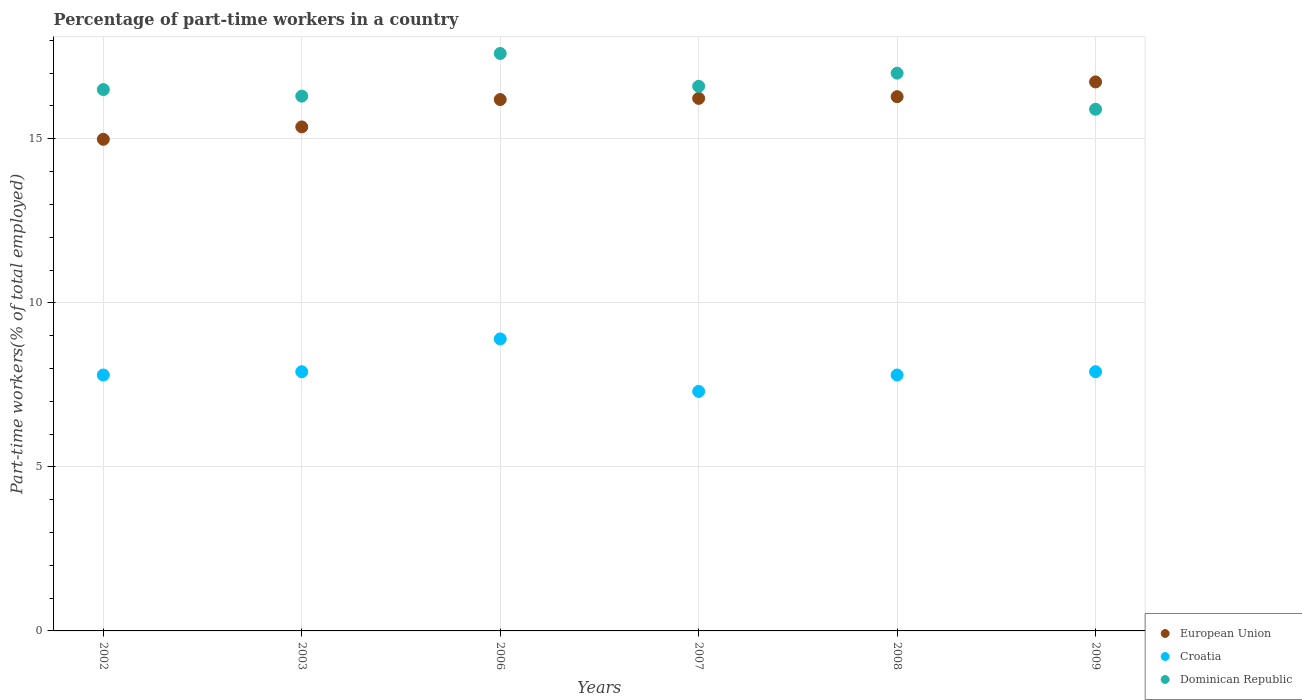How many different coloured dotlines are there?
Provide a short and direct response. 3. What is the percentage of part-time workers in Dominican Republic in 2008?
Give a very brief answer. 17. Across all years, what is the maximum percentage of part-time workers in Croatia?
Provide a short and direct response. 8.9. Across all years, what is the minimum percentage of part-time workers in Dominican Republic?
Make the answer very short. 15.9. What is the total percentage of part-time workers in European Union in the graph?
Give a very brief answer. 95.79. What is the difference between the percentage of part-time workers in Dominican Republic in 2008 and that in 2009?
Your answer should be compact. 1.1. What is the difference between the percentage of part-time workers in Dominican Republic in 2006 and the percentage of part-time workers in Croatia in 2002?
Make the answer very short. 9.8. What is the average percentage of part-time workers in European Union per year?
Your answer should be compact. 15.96. In the year 2006, what is the difference between the percentage of part-time workers in European Union and percentage of part-time workers in Croatia?
Your response must be concise. 7.3. In how many years, is the percentage of part-time workers in European Union greater than 9 %?
Offer a very short reply. 6. What is the ratio of the percentage of part-time workers in European Union in 2007 to that in 2009?
Provide a succinct answer. 0.97. Is the percentage of part-time workers in Croatia in 2007 less than that in 2009?
Offer a terse response. Yes. What is the difference between the highest and the second highest percentage of part-time workers in Dominican Republic?
Your answer should be compact. 0.6. What is the difference between the highest and the lowest percentage of part-time workers in Croatia?
Provide a succinct answer. 1.6. In how many years, is the percentage of part-time workers in European Union greater than the average percentage of part-time workers in European Union taken over all years?
Offer a very short reply. 4. Is the sum of the percentage of part-time workers in European Union in 2002 and 2006 greater than the maximum percentage of part-time workers in Croatia across all years?
Your answer should be very brief. Yes. Does the percentage of part-time workers in Dominican Republic monotonically increase over the years?
Offer a terse response. No. Is the percentage of part-time workers in Croatia strictly greater than the percentage of part-time workers in European Union over the years?
Offer a terse response. No. Is the percentage of part-time workers in European Union strictly less than the percentage of part-time workers in Dominican Republic over the years?
Your answer should be very brief. No. What is the difference between two consecutive major ticks on the Y-axis?
Make the answer very short. 5. Does the graph contain any zero values?
Make the answer very short. No. Where does the legend appear in the graph?
Your answer should be compact. Bottom right. How many legend labels are there?
Ensure brevity in your answer.  3. How are the legend labels stacked?
Your answer should be very brief. Vertical. What is the title of the graph?
Ensure brevity in your answer.  Percentage of part-time workers in a country. Does "Sub-Saharan Africa (developing only)" appear as one of the legend labels in the graph?
Make the answer very short. No. What is the label or title of the Y-axis?
Make the answer very short. Part-time workers(% of total employed). What is the Part-time workers(% of total employed) in European Union in 2002?
Your answer should be compact. 14.98. What is the Part-time workers(% of total employed) in Croatia in 2002?
Offer a terse response. 7.8. What is the Part-time workers(% of total employed) of Dominican Republic in 2002?
Make the answer very short. 16.5. What is the Part-time workers(% of total employed) in European Union in 2003?
Your answer should be compact. 15.36. What is the Part-time workers(% of total employed) of Croatia in 2003?
Ensure brevity in your answer.  7.9. What is the Part-time workers(% of total employed) of Dominican Republic in 2003?
Your response must be concise. 16.3. What is the Part-time workers(% of total employed) in European Union in 2006?
Ensure brevity in your answer.  16.2. What is the Part-time workers(% of total employed) of Croatia in 2006?
Offer a very short reply. 8.9. What is the Part-time workers(% of total employed) in Dominican Republic in 2006?
Ensure brevity in your answer.  17.6. What is the Part-time workers(% of total employed) in European Union in 2007?
Offer a terse response. 16.23. What is the Part-time workers(% of total employed) of Croatia in 2007?
Give a very brief answer. 7.3. What is the Part-time workers(% of total employed) of Dominican Republic in 2007?
Your answer should be compact. 16.6. What is the Part-time workers(% of total employed) of European Union in 2008?
Give a very brief answer. 16.28. What is the Part-time workers(% of total employed) of Croatia in 2008?
Offer a terse response. 7.8. What is the Part-time workers(% of total employed) of European Union in 2009?
Ensure brevity in your answer.  16.73. What is the Part-time workers(% of total employed) in Croatia in 2009?
Your answer should be very brief. 7.9. What is the Part-time workers(% of total employed) in Dominican Republic in 2009?
Ensure brevity in your answer.  15.9. Across all years, what is the maximum Part-time workers(% of total employed) in European Union?
Your response must be concise. 16.73. Across all years, what is the maximum Part-time workers(% of total employed) of Croatia?
Provide a short and direct response. 8.9. Across all years, what is the maximum Part-time workers(% of total employed) of Dominican Republic?
Provide a succinct answer. 17.6. Across all years, what is the minimum Part-time workers(% of total employed) in European Union?
Provide a short and direct response. 14.98. Across all years, what is the minimum Part-time workers(% of total employed) of Croatia?
Provide a short and direct response. 7.3. Across all years, what is the minimum Part-time workers(% of total employed) in Dominican Republic?
Your response must be concise. 15.9. What is the total Part-time workers(% of total employed) in European Union in the graph?
Ensure brevity in your answer.  95.79. What is the total Part-time workers(% of total employed) in Croatia in the graph?
Your response must be concise. 47.6. What is the total Part-time workers(% of total employed) in Dominican Republic in the graph?
Provide a succinct answer. 99.9. What is the difference between the Part-time workers(% of total employed) of European Union in 2002 and that in 2003?
Ensure brevity in your answer.  -0.38. What is the difference between the Part-time workers(% of total employed) of Croatia in 2002 and that in 2003?
Offer a very short reply. -0.1. What is the difference between the Part-time workers(% of total employed) in Dominican Republic in 2002 and that in 2003?
Your response must be concise. 0.2. What is the difference between the Part-time workers(% of total employed) in European Union in 2002 and that in 2006?
Offer a very short reply. -1.21. What is the difference between the Part-time workers(% of total employed) in Croatia in 2002 and that in 2006?
Keep it short and to the point. -1.1. What is the difference between the Part-time workers(% of total employed) of Dominican Republic in 2002 and that in 2006?
Ensure brevity in your answer.  -1.1. What is the difference between the Part-time workers(% of total employed) in European Union in 2002 and that in 2007?
Provide a succinct answer. -1.25. What is the difference between the Part-time workers(% of total employed) in Croatia in 2002 and that in 2007?
Provide a short and direct response. 0.5. What is the difference between the Part-time workers(% of total employed) of European Union in 2002 and that in 2008?
Your answer should be compact. -1.3. What is the difference between the Part-time workers(% of total employed) in Croatia in 2002 and that in 2008?
Provide a succinct answer. 0. What is the difference between the Part-time workers(% of total employed) in European Union in 2002 and that in 2009?
Give a very brief answer. -1.75. What is the difference between the Part-time workers(% of total employed) in European Union in 2003 and that in 2006?
Keep it short and to the point. -0.83. What is the difference between the Part-time workers(% of total employed) of European Union in 2003 and that in 2007?
Your answer should be compact. -0.87. What is the difference between the Part-time workers(% of total employed) in Dominican Republic in 2003 and that in 2007?
Make the answer very short. -0.3. What is the difference between the Part-time workers(% of total employed) in European Union in 2003 and that in 2008?
Provide a short and direct response. -0.92. What is the difference between the Part-time workers(% of total employed) of Dominican Republic in 2003 and that in 2008?
Provide a succinct answer. -0.7. What is the difference between the Part-time workers(% of total employed) in European Union in 2003 and that in 2009?
Give a very brief answer. -1.37. What is the difference between the Part-time workers(% of total employed) in European Union in 2006 and that in 2007?
Your answer should be very brief. -0.04. What is the difference between the Part-time workers(% of total employed) in Dominican Republic in 2006 and that in 2007?
Your answer should be very brief. 1. What is the difference between the Part-time workers(% of total employed) in European Union in 2006 and that in 2008?
Keep it short and to the point. -0.09. What is the difference between the Part-time workers(% of total employed) of Croatia in 2006 and that in 2008?
Give a very brief answer. 1.1. What is the difference between the Part-time workers(% of total employed) of European Union in 2006 and that in 2009?
Your answer should be very brief. -0.54. What is the difference between the Part-time workers(% of total employed) in European Union in 2007 and that in 2008?
Your answer should be very brief. -0.05. What is the difference between the Part-time workers(% of total employed) of European Union in 2007 and that in 2009?
Your answer should be very brief. -0.5. What is the difference between the Part-time workers(% of total employed) in Dominican Republic in 2007 and that in 2009?
Provide a short and direct response. 0.7. What is the difference between the Part-time workers(% of total employed) of European Union in 2008 and that in 2009?
Your response must be concise. -0.45. What is the difference between the Part-time workers(% of total employed) of Croatia in 2008 and that in 2009?
Your response must be concise. -0.1. What is the difference between the Part-time workers(% of total employed) of Dominican Republic in 2008 and that in 2009?
Make the answer very short. 1.1. What is the difference between the Part-time workers(% of total employed) of European Union in 2002 and the Part-time workers(% of total employed) of Croatia in 2003?
Provide a succinct answer. 7.08. What is the difference between the Part-time workers(% of total employed) in European Union in 2002 and the Part-time workers(% of total employed) in Dominican Republic in 2003?
Your response must be concise. -1.32. What is the difference between the Part-time workers(% of total employed) in Croatia in 2002 and the Part-time workers(% of total employed) in Dominican Republic in 2003?
Your response must be concise. -8.5. What is the difference between the Part-time workers(% of total employed) in European Union in 2002 and the Part-time workers(% of total employed) in Croatia in 2006?
Offer a very short reply. 6.08. What is the difference between the Part-time workers(% of total employed) in European Union in 2002 and the Part-time workers(% of total employed) in Dominican Republic in 2006?
Offer a very short reply. -2.62. What is the difference between the Part-time workers(% of total employed) in Croatia in 2002 and the Part-time workers(% of total employed) in Dominican Republic in 2006?
Your response must be concise. -9.8. What is the difference between the Part-time workers(% of total employed) of European Union in 2002 and the Part-time workers(% of total employed) of Croatia in 2007?
Your answer should be compact. 7.68. What is the difference between the Part-time workers(% of total employed) in European Union in 2002 and the Part-time workers(% of total employed) in Dominican Republic in 2007?
Your response must be concise. -1.62. What is the difference between the Part-time workers(% of total employed) of European Union in 2002 and the Part-time workers(% of total employed) of Croatia in 2008?
Ensure brevity in your answer.  7.18. What is the difference between the Part-time workers(% of total employed) in European Union in 2002 and the Part-time workers(% of total employed) in Dominican Republic in 2008?
Give a very brief answer. -2.02. What is the difference between the Part-time workers(% of total employed) in European Union in 2002 and the Part-time workers(% of total employed) in Croatia in 2009?
Your answer should be very brief. 7.08. What is the difference between the Part-time workers(% of total employed) in European Union in 2002 and the Part-time workers(% of total employed) in Dominican Republic in 2009?
Keep it short and to the point. -0.92. What is the difference between the Part-time workers(% of total employed) of European Union in 2003 and the Part-time workers(% of total employed) of Croatia in 2006?
Your response must be concise. 6.46. What is the difference between the Part-time workers(% of total employed) of European Union in 2003 and the Part-time workers(% of total employed) of Dominican Republic in 2006?
Provide a short and direct response. -2.24. What is the difference between the Part-time workers(% of total employed) in Croatia in 2003 and the Part-time workers(% of total employed) in Dominican Republic in 2006?
Give a very brief answer. -9.7. What is the difference between the Part-time workers(% of total employed) of European Union in 2003 and the Part-time workers(% of total employed) of Croatia in 2007?
Provide a succinct answer. 8.06. What is the difference between the Part-time workers(% of total employed) of European Union in 2003 and the Part-time workers(% of total employed) of Dominican Republic in 2007?
Your answer should be very brief. -1.24. What is the difference between the Part-time workers(% of total employed) in European Union in 2003 and the Part-time workers(% of total employed) in Croatia in 2008?
Give a very brief answer. 7.56. What is the difference between the Part-time workers(% of total employed) of European Union in 2003 and the Part-time workers(% of total employed) of Dominican Republic in 2008?
Provide a short and direct response. -1.64. What is the difference between the Part-time workers(% of total employed) in European Union in 2003 and the Part-time workers(% of total employed) in Croatia in 2009?
Provide a succinct answer. 7.46. What is the difference between the Part-time workers(% of total employed) in European Union in 2003 and the Part-time workers(% of total employed) in Dominican Republic in 2009?
Provide a succinct answer. -0.54. What is the difference between the Part-time workers(% of total employed) of Croatia in 2003 and the Part-time workers(% of total employed) of Dominican Republic in 2009?
Give a very brief answer. -8. What is the difference between the Part-time workers(% of total employed) in European Union in 2006 and the Part-time workers(% of total employed) in Croatia in 2007?
Keep it short and to the point. 8.9. What is the difference between the Part-time workers(% of total employed) of European Union in 2006 and the Part-time workers(% of total employed) of Dominican Republic in 2007?
Offer a terse response. -0.4. What is the difference between the Part-time workers(% of total employed) in European Union in 2006 and the Part-time workers(% of total employed) in Croatia in 2008?
Offer a very short reply. 8.4. What is the difference between the Part-time workers(% of total employed) of European Union in 2006 and the Part-time workers(% of total employed) of Dominican Republic in 2008?
Offer a terse response. -0.8. What is the difference between the Part-time workers(% of total employed) in Croatia in 2006 and the Part-time workers(% of total employed) in Dominican Republic in 2008?
Ensure brevity in your answer.  -8.1. What is the difference between the Part-time workers(% of total employed) of European Union in 2006 and the Part-time workers(% of total employed) of Croatia in 2009?
Offer a very short reply. 8.3. What is the difference between the Part-time workers(% of total employed) in European Union in 2006 and the Part-time workers(% of total employed) in Dominican Republic in 2009?
Your response must be concise. 0.3. What is the difference between the Part-time workers(% of total employed) in European Union in 2007 and the Part-time workers(% of total employed) in Croatia in 2008?
Keep it short and to the point. 8.43. What is the difference between the Part-time workers(% of total employed) in European Union in 2007 and the Part-time workers(% of total employed) in Dominican Republic in 2008?
Keep it short and to the point. -0.77. What is the difference between the Part-time workers(% of total employed) in European Union in 2007 and the Part-time workers(% of total employed) in Croatia in 2009?
Your response must be concise. 8.33. What is the difference between the Part-time workers(% of total employed) of European Union in 2007 and the Part-time workers(% of total employed) of Dominican Republic in 2009?
Your answer should be compact. 0.33. What is the difference between the Part-time workers(% of total employed) of European Union in 2008 and the Part-time workers(% of total employed) of Croatia in 2009?
Your response must be concise. 8.38. What is the difference between the Part-time workers(% of total employed) in European Union in 2008 and the Part-time workers(% of total employed) in Dominican Republic in 2009?
Your answer should be very brief. 0.38. What is the difference between the Part-time workers(% of total employed) in Croatia in 2008 and the Part-time workers(% of total employed) in Dominican Republic in 2009?
Offer a terse response. -8.1. What is the average Part-time workers(% of total employed) in European Union per year?
Make the answer very short. 15.96. What is the average Part-time workers(% of total employed) in Croatia per year?
Make the answer very short. 7.93. What is the average Part-time workers(% of total employed) in Dominican Republic per year?
Offer a terse response. 16.65. In the year 2002, what is the difference between the Part-time workers(% of total employed) of European Union and Part-time workers(% of total employed) of Croatia?
Ensure brevity in your answer.  7.18. In the year 2002, what is the difference between the Part-time workers(% of total employed) of European Union and Part-time workers(% of total employed) of Dominican Republic?
Keep it short and to the point. -1.52. In the year 2002, what is the difference between the Part-time workers(% of total employed) of Croatia and Part-time workers(% of total employed) of Dominican Republic?
Keep it short and to the point. -8.7. In the year 2003, what is the difference between the Part-time workers(% of total employed) in European Union and Part-time workers(% of total employed) in Croatia?
Offer a terse response. 7.46. In the year 2003, what is the difference between the Part-time workers(% of total employed) of European Union and Part-time workers(% of total employed) of Dominican Republic?
Ensure brevity in your answer.  -0.94. In the year 2006, what is the difference between the Part-time workers(% of total employed) in European Union and Part-time workers(% of total employed) in Croatia?
Make the answer very short. 7.3. In the year 2006, what is the difference between the Part-time workers(% of total employed) of European Union and Part-time workers(% of total employed) of Dominican Republic?
Your answer should be compact. -1.4. In the year 2007, what is the difference between the Part-time workers(% of total employed) of European Union and Part-time workers(% of total employed) of Croatia?
Keep it short and to the point. 8.93. In the year 2007, what is the difference between the Part-time workers(% of total employed) in European Union and Part-time workers(% of total employed) in Dominican Republic?
Make the answer very short. -0.37. In the year 2007, what is the difference between the Part-time workers(% of total employed) of Croatia and Part-time workers(% of total employed) of Dominican Republic?
Provide a short and direct response. -9.3. In the year 2008, what is the difference between the Part-time workers(% of total employed) in European Union and Part-time workers(% of total employed) in Croatia?
Provide a succinct answer. 8.48. In the year 2008, what is the difference between the Part-time workers(% of total employed) in European Union and Part-time workers(% of total employed) in Dominican Republic?
Keep it short and to the point. -0.72. In the year 2009, what is the difference between the Part-time workers(% of total employed) of European Union and Part-time workers(% of total employed) of Croatia?
Offer a very short reply. 8.83. In the year 2009, what is the difference between the Part-time workers(% of total employed) in European Union and Part-time workers(% of total employed) in Dominican Republic?
Provide a short and direct response. 0.83. What is the ratio of the Part-time workers(% of total employed) in European Union in 2002 to that in 2003?
Keep it short and to the point. 0.98. What is the ratio of the Part-time workers(% of total employed) of Croatia in 2002 to that in 2003?
Give a very brief answer. 0.99. What is the ratio of the Part-time workers(% of total employed) of Dominican Republic in 2002 to that in 2003?
Give a very brief answer. 1.01. What is the ratio of the Part-time workers(% of total employed) of European Union in 2002 to that in 2006?
Offer a very short reply. 0.93. What is the ratio of the Part-time workers(% of total employed) in Croatia in 2002 to that in 2006?
Give a very brief answer. 0.88. What is the ratio of the Part-time workers(% of total employed) of European Union in 2002 to that in 2007?
Ensure brevity in your answer.  0.92. What is the ratio of the Part-time workers(% of total employed) of Croatia in 2002 to that in 2007?
Your answer should be compact. 1.07. What is the ratio of the Part-time workers(% of total employed) in Dominican Republic in 2002 to that in 2007?
Ensure brevity in your answer.  0.99. What is the ratio of the Part-time workers(% of total employed) in European Union in 2002 to that in 2008?
Give a very brief answer. 0.92. What is the ratio of the Part-time workers(% of total employed) in Croatia in 2002 to that in 2008?
Ensure brevity in your answer.  1. What is the ratio of the Part-time workers(% of total employed) of Dominican Republic in 2002 to that in 2008?
Offer a very short reply. 0.97. What is the ratio of the Part-time workers(% of total employed) of European Union in 2002 to that in 2009?
Provide a succinct answer. 0.9. What is the ratio of the Part-time workers(% of total employed) of Croatia in 2002 to that in 2009?
Your response must be concise. 0.99. What is the ratio of the Part-time workers(% of total employed) of Dominican Republic in 2002 to that in 2009?
Give a very brief answer. 1.04. What is the ratio of the Part-time workers(% of total employed) of European Union in 2003 to that in 2006?
Offer a very short reply. 0.95. What is the ratio of the Part-time workers(% of total employed) in Croatia in 2003 to that in 2006?
Your answer should be very brief. 0.89. What is the ratio of the Part-time workers(% of total employed) in Dominican Republic in 2003 to that in 2006?
Ensure brevity in your answer.  0.93. What is the ratio of the Part-time workers(% of total employed) of European Union in 2003 to that in 2007?
Ensure brevity in your answer.  0.95. What is the ratio of the Part-time workers(% of total employed) in Croatia in 2003 to that in 2007?
Offer a terse response. 1.08. What is the ratio of the Part-time workers(% of total employed) in Dominican Republic in 2003 to that in 2007?
Offer a terse response. 0.98. What is the ratio of the Part-time workers(% of total employed) of European Union in 2003 to that in 2008?
Offer a very short reply. 0.94. What is the ratio of the Part-time workers(% of total employed) in Croatia in 2003 to that in 2008?
Give a very brief answer. 1.01. What is the ratio of the Part-time workers(% of total employed) in Dominican Republic in 2003 to that in 2008?
Provide a succinct answer. 0.96. What is the ratio of the Part-time workers(% of total employed) in European Union in 2003 to that in 2009?
Ensure brevity in your answer.  0.92. What is the ratio of the Part-time workers(% of total employed) of Dominican Republic in 2003 to that in 2009?
Your answer should be compact. 1.03. What is the ratio of the Part-time workers(% of total employed) of European Union in 2006 to that in 2007?
Your answer should be very brief. 1. What is the ratio of the Part-time workers(% of total employed) of Croatia in 2006 to that in 2007?
Make the answer very short. 1.22. What is the ratio of the Part-time workers(% of total employed) in Dominican Republic in 2006 to that in 2007?
Make the answer very short. 1.06. What is the ratio of the Part-time workers(% of total employed) of European Union in 2006 to that in 2008?
Your answer should be very brief. 0.99. What is the ratio of the Part-time workers(% of total employed) in Croatia in 2006 to that in 2008?
Ensure brevity in your answer.  1.14. What is the ratio of the Part-time workers(% of total employed) in Dominican Republic in 2006 to that in 2008?
Offer a terse response. 1.04. What is the ratio of the Part-time workers(% of total employed) in European Union in 2006 to that in 2009?
Ensure brevity in your answer.  0.97. What is the ratio of the Part-time workers(% of total employed) of Croatia in 2006 to that in 2009?
Offer a very short reply. 1.13. What is the ratio of the Part-time workers(% of total employed) of Dominican Republic in 2006 to that in 2009?
Your answer should be compact. 1.11. What is the ratio of the Part-time workers(% of total employed) in Croatia in 2007 to that in 2008?
Your answer should be very brief. 0.94. What is the ratio of the Part-time workers(% of total employed) of Dominican Republic in 2007 to that in 2008?
Keep it short and to the point. 0.98. What is the ratio of the Part-time workers(% of total employed) in European Union in 2007 to that in 2009?
Your response must be concise. 0.97. What is the ratio of the Part-time workers(% of total employed) in Croatia in 2007 to that in 2009?
Your answer should be very brief. 0.92. What is the ratio of the Part-time workers(% of total employed) in Dominican Republic in 2007 to that in 2009?
Your answer should be very brief. 1.04. What is the ratio of the Part-time workers(% of total employed) in European Union in 2008 to that in 2009?
Give a very brief answer. 0.97. What is the ratio of the Part-time workers(% of total employed) of Croatia in 2008 to that in 2009?
Give a very brief answer. 0.99. What is the ratio of the Part-time workers(% of total employed) of Dominican Republic in 2008 to that in 2009?
Provide a short and direct response. 1.07. What is the difference between the highest and the second highest Part-time workers(% of total employed) in European Union?
Keep it short and to the point. 0.45. What is the difference between the highest and the second highest Part-time workers(% of total employed) in Croatia?
Offer a very short reply. 1. What is the difference between the highest and the lowest Part-time workers(% of total employed) in European Union?
Ensure brevity in your answer.  1.75. What is the difference between the highest and the lowest Part-time workers(% of total employed) of Dominican Republic?
Make the answer very short. 1.7. 